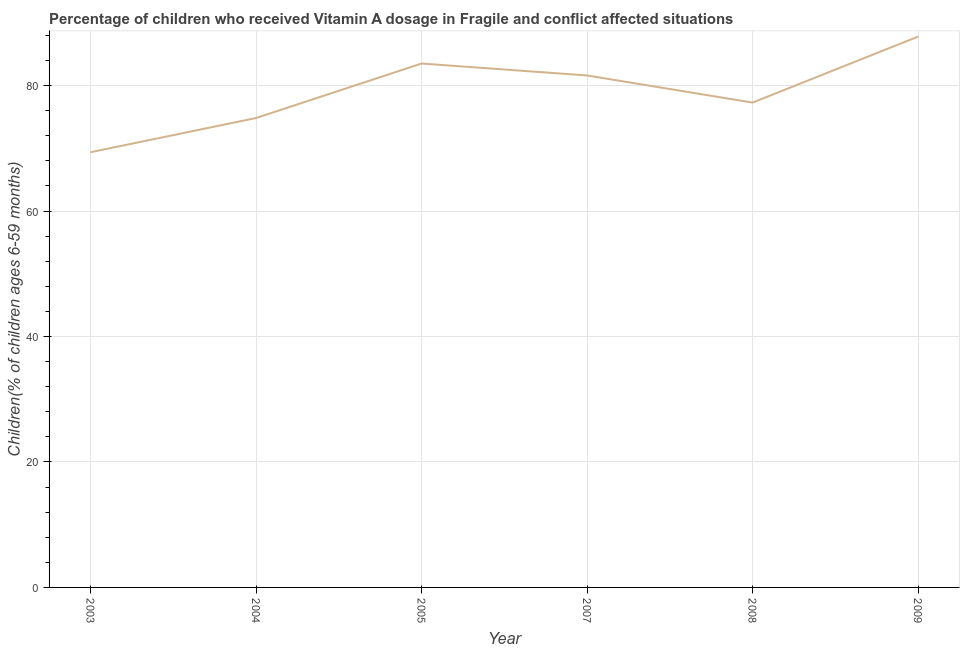What is the vitamin a supplementation coverage rate in 2009?
Offer a very short reply. 87.8. Across all years, what is the maximum vitamin a supplementation coverage rate?
Your answer should be very brief. 87.8. Across all years, what is the minimum vitamin a supplementation coverage rate?
Your response must be concise. 69.37. In which year was the vitamin a supplementation coverage rate maximum?
Your response must be concise. 2009. In which year was the vitamin a supplementation coverage rate minimum?
Offer a terse response. 2003. What is the sum of the vitamin a supplementation coverage rate?
Make the answer very short. 474.41. What is the difference between the vitamin a supplementation coverage rate in 2003 and 2009?
Your answer should be very brief. -18.43. What is the average vitamin a supplementation coverage rate per year?
Make the answer very short. 79.07. What is the median vitamin a supplementation coverage rate?
Your answer should be compact. 79.45. In how many years, is the vitamin a supplementation coverage rate greater than 64 %?
Provide a short and direct response. 6. What is the ratio of the vitamin a supplementation coverage rate in 2005 to that in 2007?
Offer a very short reply. 1.02. Is the vitamin a supplementation coverage rate in 2004 less than that in 2008?
Ensure brevity in your answer.  Yes. What is the difference between the highest and the second highest vitamin a supplementation coverage rate?
Offer a very short reply. 4.29. What is the difference between the highest and the lowest vitamin a supplementation coverage rate?
Your response must be concise. 18.43. Does the vitamin a supplementation coverage rate monotonically increase over the years?
Offer a very short reply. No. Does the graph contain any zero values?
Provide a short and direct response. No. What is the title of the graph?
Keep it short and to the point. Percentage of children who received Vitamin A dosage in Fragile and conflict affected situations. What is the label or title of the X-axis?
Make the answer very short. Year. What is the label or title of the Y-axis?
Offer a very short reply. Children(% of children ages 6-59 months). What is the Children(% of children ages 6-59 months) of 2003?
Your response must be concise. 69.37. What is the Children(% of children ages 6-59 months) in 2004?
Your answer should be compact. 74.83. What is the Children(% of children ages 6-59 months) in 2005?
Your answer should be very brief. 83.51. What is the Children(% of children ages 6-59 months) in 2007?
Ensure brevity in your answer.  81.61. What is the Children(% of children ages 6-59 months) in 2008?
Your answer should be very brief. 77.28. What is the Children(% of children ages 6-59 months) of 2009?
Make the answer very short. 87.8. What is the difference between the Children(% of children ages 6-59 months) in 2003 and 2004?
Offer a terse response. -5.45. What is the difference between the Children(% of children ages 6-59 months) in 2003 and 2005?
Provide a short and direct response. -14.14. What is the difference between the Children(% of children ages 6-59 months) in 2003 and 2007?
Your response must be concise. -12.24. What is the difference between the Children(% of children ages 6-59 months) in 2003 and 2008?
Provide a succinct answer. -7.91. What is the difference between the Children(% of children ages 6-59 months) in 2003 and 2009?
Your answer should be compact. -18.43. What is the difference between the Children(% of children ages 6-59 months) in 2004 and 2005?
Provide a short and direct response. -8.69. What is the difference between the Children(% of children ages 6-59 months) in 2004 and 2007?
Ensure brevity in your answer.  -6.78. What is the difference between the Children(% of children ages 6-59 months) in 2004 and 2008?
Offer a very short reply. -2.46. What is the difference between the Children(% of children ages 6-59 months) in 2004 and 2009?
Keep it short and to the point. -12.98. What is the difference between the Children(% of children ages 6-59 months) in 2005 and 2007?
Keep it short and to the point. 1.9. What is the difference between the Children(% of children ages 6-59 months) in 2005 and 2008?
Offer a very short reply. 6.23. What is the difference between the Children(% of children ages 6-59 months) in 2005 and 2009?
Your response must be concise. -4.29. What is the difference between the Children(% of children ages 6-59 months) in 2007 and 2008?
Your response must be concise. 4.33. What is the difference between the Children(% of children ages 6-59 months) in 2007 and 2009?
Your answer should be very brief. -6.19. What is the difference between the Children(% of children ages 6-59 months) in 2008 and 2009?
Your answer should be very brief. -10.52. What is the ratio of the Children(% of children ages 6-59 months) in 2003 to that in 2004?
Make the answer very short. 0.93. What is the ratio of the Children(% of children ages 6-59 months) in 2003 to that in 2005?
Make the answer very short. 0.83. What is the ratio of the Children(% of children ages 6-59 months) in 2003 to that in 2007?
Provide a succinct answer. 0.85. What is the ratio of the Children(% of children ages 6-59 months) in 2003 to that in 2008?
Your response must be concise. 0.9. What is the ratio of the Children(% of children ages 6-59 months) in 2003 to that in 2009?
Offer a terse response. 0.79. What is the ratio of the Children(% of children ages 6-59 months) in 2004 to that in 2005?
Make the answer very short. 0.9. What is the ratio of the Children(% of children ages 6-59 months) in 2004 to that in 2007?
Keep it short and to the point. 0.92. What is the ratio of the Children(% of children ages 6-59 months) in 2004 to that in 2009?
Make the answer very short. 0.85. What is the ratio of the Children(% of children ages 6-59 months) in 2005 to that in 2007?
Make the answer very short. 1.02. What is the ratio of the Children(% of children ages 6-59 months) in 2005 to that in 2008?
Your answer should be compact. 1.08. What is the ratio of the Children(% of children ages 6-59 months) in 2005 to that in 2009?
Your answer should be very brief. 0.95. What is the ratio of the Children(% of children ages 6-59 months) in 2007 to that in 2008?
Your response must be concise. 1.06. What is the ratio of the Children(% of children ages 6-59 months) in 2007 to that in 2009?
Ensure brevity in your answer.  0.93. What is the ratio of the Children(% of children ages 6-59 months) in 2008 to that in 2009?
Give a very brief answer. 0.88. 